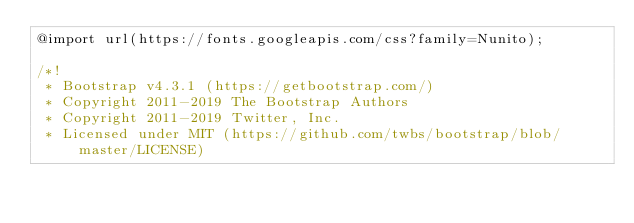Convert code to text. <code><loc_0><loc_0><loc_500><loc_500><_CSS_>@import url(https://fonts.googleapis.com/css?family=Nunito);

/*!
 * Bootstrap v4.3.1 (https://getbootstrap.com/)
 * Copyright 2011-2019 The Bootstrap Authors
 * Copyright 2011-2019 Twitter, Inc.
 * Licensed under MIT (https://github.com/twbs/bootstrap/blob/master/LICENSE)</code> 